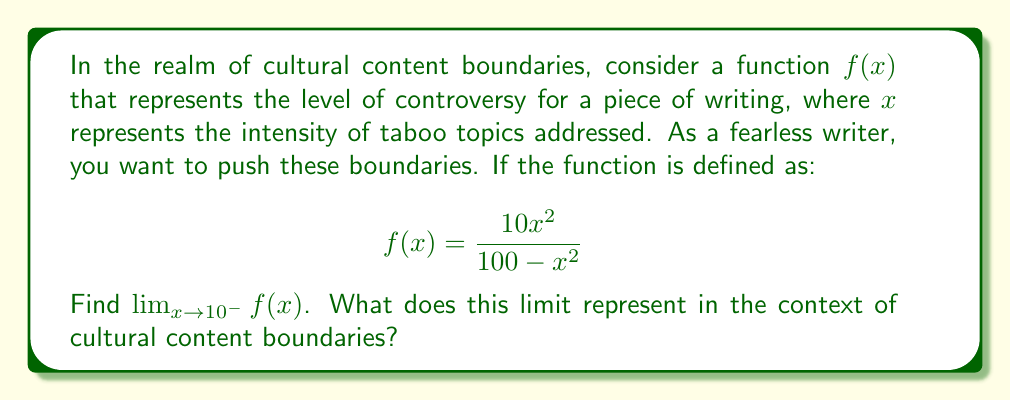Solve this math problem. To solve this limit problem and interpret its meaning:

1) First, let's examine the function:
   $$f(x) = \frac{10x^2}{100-x^2}$$

2) We're asked to find the limit as $x$ approaches 10 from the left side:
   $$\lim_{x \to 10^-} \frac{10x^2}{100-x^2}$$

3) Let's try direct substitution:
   $$\frac{10(10)^2}{100-(10)^2} = \frac{1000}{0}$$

4) This results in an undefined expression (division by zero), indicating a vertical asymptote at $x=10$.

5) To find the limit, we can use the fact that as $x$ approaches 10 from the left, the denominator approaches 0 from the right, while the numerator grows large.

6) Therefore:
   $$\lim_{x \to 10^-} \frac{10x^2}{100-x^2} = +\infty$$

Interpretation:
In the context of cultural content boundaries, this limit represents an approach to an absolute threshold of controversial content. As a fearless writer pushes closer to this boundary (x approaching 10), the level of controversy (f(x)) approaches infinity. The vertical asymptote at x=10 could represent a point beyond which content becomes universally unacceptable or creates infinite controversy across all cultures.
Answer: $$\lim_{x \to 10^-} \frac{10x^2}{100-x^2} = +\infty$$ 